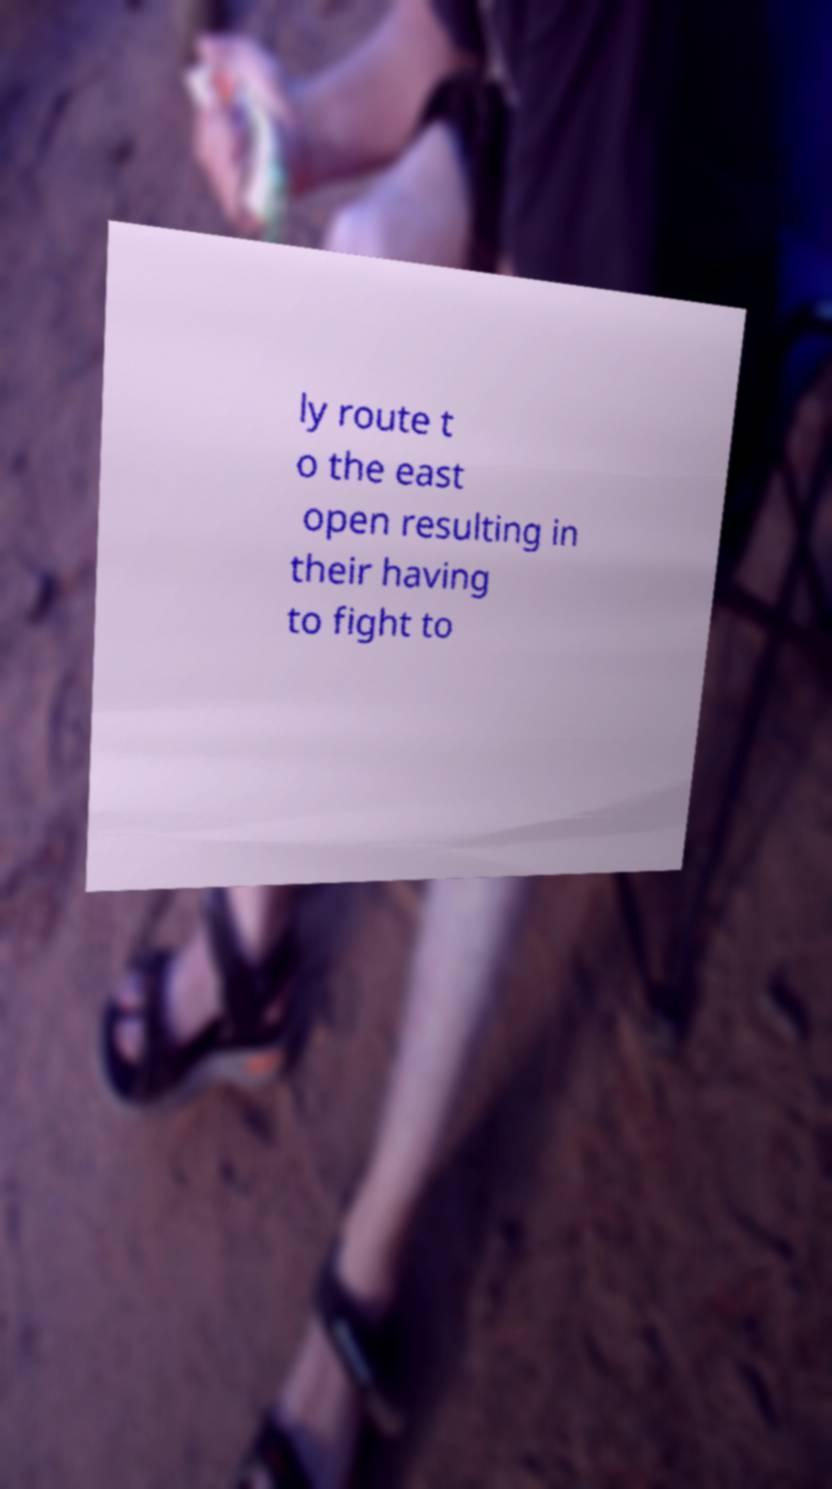Please read and relay the text visible in this image. What does it say? ly route t o the east open resulting in their having to fight to 